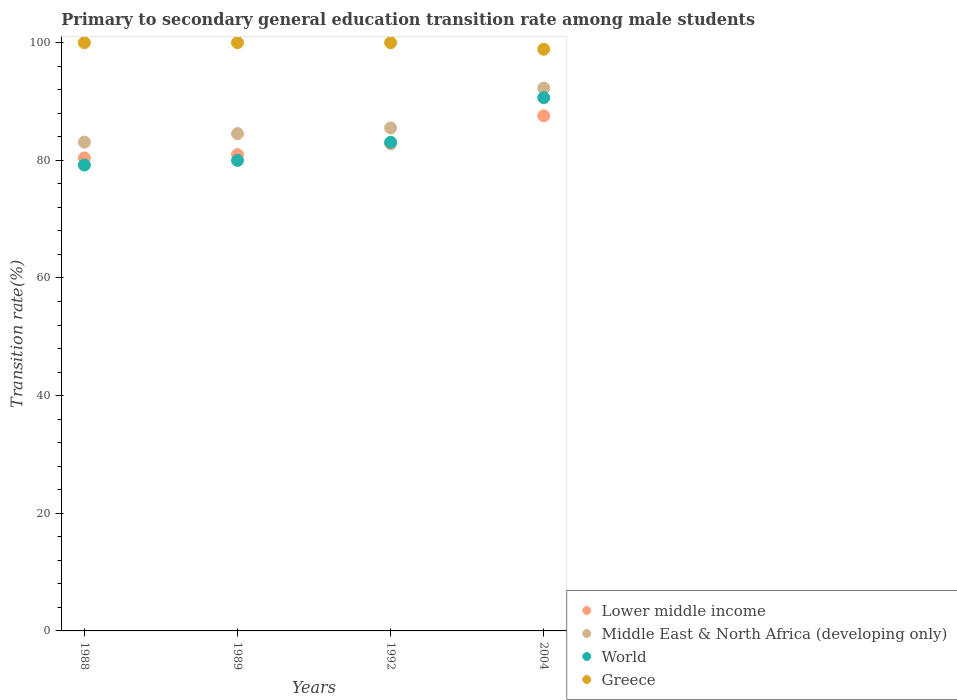How many different coloured dotlines are there?
Make the answer very short. 4. What is the transition rate in Greece in 2004?
Your answer should be compact. 98.88. Across all years, what is the maximum transition rate in World?
Offer a very short reply. 90.65. Across all years, what is the minimum transition rate in Lower middle income?
Offer a terse response. 80.41. What is the total transition rate in Lower middle income in the graph?
Provide a succinct answer. 331.79. What is the difference between the transition rate in Lower middle income in 1988 and that in 1989?
Your response must be concise. -0.56. What is the difference between the transition rate in Greece in 1992 and the transition rate in Lower middle income in 1989?
Keep it short and to the point. 19.02. What is the average transition rate in Lower middle income per year?
Provide a succinct answer. 82.95. In the year 2004, what is the difference between the transition rate in Lower middle income and transition rate in Middle East & North Africa (developing only)?
Keep it short and to the point. -4.71. What is the ratio of the transition rate in Greece in 1992 to that in 2004?
Offer a terse response. 1.01. Is the transition rate in Greece in 1989 less than that in 1992?
Your answer should be very brief. No. What is the difference between the highest and the lowest transition rate in World?
Offer a very short reply. 11.45. In how many years, is the transition rate in Lower middle income greater than the average transition rate in Lower middle income taken over all years?
Offer a terse response. 1. Is the sum of the transition rate in Middle East & North Africa (developing only) in 1992 and 2004 greater than the maximum transition rate in World across all years?
Provide a short and direct response. Yes. Is it the case that in every year, the sum of the transition rate in Middle East & North Africa (developing only) and transition rate in World  is greater than the sum of transition rate in Lower middle income and transition rate in Greece?
Your answer should be compact. No. Does the transition rate in World monotonically increase over the years?
Provide a succinct answer. Yes. Is the transition rate in Lower middle income strictly greater than the transition rate in Middle East & North Africa (developing only) over the years?
Offer a very short reply. No. Is the transition rate in Lower middle income strictly less than the transition rate in World over the years?
Offer a very short reply. No. How many years are there in the graph?
Give a very brief answer. 4. What is the difference between two consecutive major ticks on the Y-axis?
Offer a terse response. 20. Are the values on the major ticks of Y-axis written in scientific E-notation?
Give a very brief answer. No. Does the graph contain any zero values?
Ensure brevity in your answer.  No. Does the graph contain grids?
Your answer should be compact. No. How are the legend labels stacked?
Your answer should be very brief. Vertical. What is the title of the graph?
Keep it short and to the point. Primary to secondary general education transition rate among male students. What is the label or title of the X-axis?
Provide a succinct answer. Years. What is the label or title of the Y-axis?
Give a very brief answer. Transition rate(%). What is the Transition rate(%) in Lower middle income in 1988?
Your response must be concise. 80.41. What is the Transition rate(%) of Middle East & North Africa (developing only) in 1988?
Offer a very short reply. 83.1. What is the Transition rate(%) of World in 1988?
Ensure brevity in your answer.  79.2. What is the Transition rate(%) of Greece in 1988?
Your answer should be very brief. 100. What is the Transition rate(%) of Lower middle income in 1989?
Your answer should be very brief. 80.98. What is the Transition rate(%) of Middle East & North Africa (developing only) in 1989?
Give a very brief answer. 84.54. What is the Transition rate(%) in World in 1989?
Keep it short and to the point. 79.98. What is the Transition rate(%) in Lower middle income in 1992?
Give a very brief answer. 82.83. What is the Transition rate(%) of Middle East & North Africa (developing only) in 1992?
Offer a very short reply. 85.51. What is the Transition rate(%) of World in 1992?
Offer a terse response. 83.07. What is the Transition rate(%) of Greece in 1992?
Ensure brevity in your answer.  100. What is the Transition rate(%) in Lower middle income in 2004?
Your response must be concise. 87.57. What is the Transition rate(%) of Middle East & North Africa (developing only) in 2004?
Ensure brevity in your answer.  92.29. What is the Transition rate(%) of World in 2004?
Offer a terse response. 90.65. What is the Transition rate(%) in Greece in 2004?
Give a very brief answer. 98.88. Across all years, what is the maximum Transition rate(%) of Lower middle income?
Ensure brevity in your answer.  87.57. Across all years, what is the maximum Transition rate(%) in Middle East & North Africa (developing only)?
Provide a succinct answer. 92.29. Across all years, what is the maximum Transition rate(%) in World?
Provide a short and direct response. 90.65. Across all years, what is the maximum Transition rate(%) in Greece?
Provide a short and direct response. 100. Across all years, what is the minimum Transition rate(%) of Lower middle income?
Offer a very short reply. 80.41. Across all years, what is the minimum Transition rate(%) of Middle East & North Africa (developing only)?
Your answer should be very brief. 83.1. Across all years, what is the minimum Transition rate(%) in World?
Give a very brief answer. 79.2. Across all years, what is the minimum Transition rate(%) in Greece?
Offer a terse response. 98.88. What is the total Transition rate(%) of Lower middle income in the graph?
Provide a succinct answer. 331.79. What is the total Transition rate(%) in Middle East & North Africa (developing only) in the graph?
Offer a very short reply. 345.44. What is the total Transition rate(%) of World in the graph?
Give a very brief answer. 332.9. What is the total Transition rate(%) of Greece in the graph?
Your answer should be very brief. 398.88. What is the difference between the Transition rate(%) of Lower middle income in 1988 and that in 1989?
Your answer should be very brief. -0.56. What is the difference between the Transition rate(%) in Middle East & North Africa (developing only) in 1988 and that in 1989?
Keep it short and to the point. -1.45. What is the difference between the Transition rate(%) in World in 1988 and that in 1989?
Your answer should be very brief. -0.78. What is the difference between the Transition rate(%) of Lower middle income in 1988 and that in 1992?
Offer a very short reply. -2.42. What is the difference between the Transition rate(%) in Middle East & North Africa (developing only) in 1988 and that in 1992?
Keep it short and to the point. -2.41. What is the difference between the Transition rate(%) of World in 1988 and that in 1992?
Ensure brevity in your answer.  -3.87. What is the difference between the Transition rate(%) of Greece in 1988 and that in 1992?
Your answer should be compact. 0. What is the difference between the Transition rate(%) in Lower middle income in 1988 and that in 2004?
Give a very brief answer. -7.16. What is the difference between the Transition rate(%) in Middle East & North Africa (developing only) in 1988 and that in 2004?
Your response must be concise. -9.19. What is the difference between the Transition rate(%) in World in 1988 and that in 2004?
Your response must be concise. -11.45. What is the difference between the Transition rate(%) in Greece in 1988 and that in 2004?
Make the answer very short. 1.12. What is the difference between the Transition rate(%) of Lower middle income in 1989 and that in 1992?
Offer a terse response. -1.86. What is the difference between the Transition rate(%) of Middle East & North Africa (developing only) in 1989 and that in 1992?
Your answer should be very brief. -0.96. What is the difference between the Transition rate(%) of World in 1989 and that in 1992?
Offer a very short reply. -3.08. What is the difference between the Transition rate(%) in Lower middle income in 1989 and that in 2004?
Make the answer very short. -6.6. What is the difference between the Transition rate(%) of Middle East & North Africa (developing only) in 1989 and that in 2004?
Your response must be concise. -7.74. What is the difference between the Transition rate(%) in World in 1989 and that in 2004?
Your answer should be compact. -10.67. What is the difference between the Transition rate(%) in Greece in 1989 and that in 2004?
Your answer should be very brief. 1.12. What is the difference between the Transition rate(%) of Lower middle income in 1992 and that in 2004?
Make the answer very short. -4.74. What is the difference between the Transition rate(%) in Middle East & North Africa (developing only) in 1992 and that in 2004?
Your answer should be compact. -6.78. What is the difference between the Transition rate(%) in World in 1992 and that in 2004?
Keep it short and to the point. -7.58. What is the difference between the Transition rate(%) in Greece in 1992 and that in 2004?
Your answer should be compact. 1.12. What is the difference between the Transition rate(%) of Lower middle income in 1988 and the Transition rate(%) of Middle East & North Africa (developing only) in 1989?
Keep it short and to the point. -4.13. What is the difference between the Transition rate(%) in Lower middle income in 1988 and the Transition rate(%) in World in 1989?
Your answer should be compact. 0.43. What is the difference between the Transition rate(%) of Lower middle income in 1988 and the Transition rate(%) of Greece in 1989?
Provide a succinct answer. -19.59. What is the difference between the Transition rate(%) of Middle East & North Africa (developing only) in 1988 and the Transition rate(%) of World in 1989?
Provide a succinct answer. 3.11. What is the difference between the Transition rate(%) of Middle East & North Africa (developing only) in 1988 and the Transition rate(%) of Greece in 1989?
Your response must be concise. -16.9. What is the difference between the Transition rate(%) in World in 1988 and the Transition rate(%) in Greece in 1989?
Ensure brevity in your answer.  -20.8. What is the difference between the Transition rate(%) of Lower middle income in 1988 and the Transition rate(%) of Middle East & North Africa (developing only) in 1992?
Provide a short and direct response. -5.1. What is the difference between the Transition rate(%) of Lower middle income in 1988 and the Transition rate(%) of World in 1992?
Provide a short and direct response. -2.66. What is the difference between the Transition rate(%) of Lower middle income in 1988 and the Transition rate(%) of Greece in 1992?
Your answer should be compact. -19.59. What is the difference between the Transition rate(%) of Middle East & North Africa (developing only) in 1988 and the Transition rate(%) of Greece in 1992?
Your response must be concise. -16.9. What is the difference between the Transition rate(%) of World in 1988 and the Transition rate(%) of Greece in 1992?
Provide a short and direct response. -20.8. What is the difference between the Transition rate(%) in Lower middle income in 1988 and the Transition rate(%) in Middle East & North Africa (developing only) in 2004?
Provide a succinct answer. -11.88. What is the difference between the Transition rate(%) of Lower middle income in 1988 and the Transition rate(%) of World in 2004?
Your answer should be compact. -10.24. What is the difference between the Transition rate(%) in Lower middle income in 1988 and the Transition rate(%) in Greece in 2004?
Keep it short and to the point. -18.47. What is the difference between the Transition rate(%) of Middle East & North Africa (developing only) in 1988 and the Transition rate(%) of World in 2004?
Offer a terse response. -7.55. What is the difference between the Transition rate(%) in Middle East & North Africa (developing only) in 1988 and the Transition rate(%) in Greece in 2004?
Offer a very short reply. -15.79. What is the difference between the Transition rate(%) in World in 1988 and the Transition rate(%) in Greece in 2004?
Offer a very short reply. -19.68. What is the difference between the Transition rate(%) in Lower middle income in 1989 and the Transition rate(%) in Middle East & North Africa (developing only) in 1992?
Give a very brief answer. -4.53. What is the difference between the Transition rate(%) in Lower middle income in 1989 and the Transition rate(%) in World in 1992?
Your response must be concise. -2.09. What is the difference between the Transition rate(%) of Lower middle income in 1989 and the Transition rate(%) of Greece in 1992?
Give a very brief answer. -19.02. What is the difference between the Transition rate(%) of Middle East & North Africa (developing only) in 1989 and the Transition rate(%) of World in 1992?
Keep it short and to the point. 1.48. What is the difference between the Transition rate(%) of Middle East & North Africa (developing only) in 1989 and the Transition rate(%) of Greece in 1992?
Provide a succinct answer. -15.46. What is the difference between the Transition rate(%) of World in 1989 and the Transition rate(%) of Greece in 1992?
Give a very brief answer. -20.02. What is the difference between the Transition rate(%) in Lower middle income in 1989 and the Transition rate(%) in Middle East & North Africa (developing only) in 2004?
Your response must be concise. -11.31. What is the difference between the Transition rate(%) in Lower middle income in 1989 and the Transition rate(%) in World in 2004?
Your response must be concise. -9.68. What is the difference between the Transition rate(%) of Lower middle income in 1989 and the Transition rate(%) of Greece in 2004?
Keep it short and to the point. -17.91. What is the difference between the Transition rate(%) of Middle East & North Africa (developing only) in 1989 and the Transition rate(%) of World in 2004?
Make the answer very short. -6.11. What is the difference between the Transition rate(%) in Middle East & North Africa (developing only) in 1989 and the Transition rate(%) in Greece in 2004?
Your response must be concise. -14.34. What is the difference between the Transition rate(%) of World in 1989 and the Transition rate(%) of Greece in 2004?
Keep it short and to the point. -18.9. What is the difference between the Transition rate(%) of Lower middle income in 1992 and the Transition rate(%) of Middle East & North Africa (developing only) in 2004?
Make the answer very short. -9.46. What is the difference between the Transition rate(%) of Lower middle income in 1992 and the Transition rate(%) of World in 2004?
Your response must be concise. -7.82. What is the difference between the Transition rate(%) in Lower middle income in 1992 and the Transition rate(%) in Greece in 2004?
Provide a short and direct response. -16.05. What is the difference between the Transition rate(%) in Middle East & North Africa (developing only) in 1992 and the Transition rate(%) in World in 2004?
Provide a succinct answer. -5.14. What is the difference between the Transition rate(%) of Middle East & North Africa (developing only) in 1992 and the Transition rate(%) of Greece in 2004?
Ensure brevity in your answer.  -13.38. What is the difference between the Transition rate(%) of World in 1992 and the Transition rate(%) of Greece in 2004?
Give a very brief answer. -15.82. What is the average Transition rate(%) in Lower middle income per year?
Your response must be concise. 82.95. What is the average Transition rate(%) in Middle East & North Africa (developing only) per year?
Your answer should be compact. 86.36. What is the average Transition rate(%) of World per year?
Make the answer very short. 83.23. What is the average Transition rate(%) in Greece per year?
Ensure brevity in your answer.  99.72. In the year 1988, what is the difference between the Transition rate(%) of Lower middle income and Transition rate(%) of Middle East & North Africa (developing only)?
Your answer should be compact. -2.69. In the year 1988, what is the difference between the Transition rate(%) of Lower middle income and Transition rate(%) of World?
Offer a terse response. 1.21. In the year 1988, what is the difference between the Transition rate(%) of Lower middle income and Transition rate(%) of Greece?
Your answer should be compact. -19.59. In the year 1988, what is the difference between the Transition rate(%) of Middle East & North Africa (developing only) and Transition rate(%) of World?
Your answer should be compact. 3.9. In the year 1988, what is the difference between the Transition rate(%) in Middle East & North Africa (developing only) and Transition rate(%) in Greece?
Provide a succinct answer. -16.9. In the year 1988, what is the difference between the Transition rate(%) of World and Transition rate(%) of Greece?
Keep it short and to the point. -20.8. In the year 1989, what is the difference between the Transition rate(%) of Lower middle income and Transition rate(%) of Middle East & North Africa (developing only)?
Offer a terse response. -3.57. In the year 1989, what is the difference between the Transition rate(%) of Lower middle income and Transition rate(%) of Greece?
Your answer should be very brief. -19.02. In the year 1989, what is the difference between the Transition rate(%) in Middle East & North Africa (developing only) and Transition rate(%) in World?
Your answer should be compact. 4.56. In the year 1989, what is the difference between the Transition rate(%) in Middle East & North Africa (developing only) and Transition rate(%) in Greece?
Give a very brief answer. -15.46. In the year 1989, what is the difference between the Transition rate(%) of World and Transition rate(%) of Greece?
Provide a short and direct response. -20.02. In the year 1992, what is the difference between the Transition rate(%) of Lower middle income and Transition rate(%) of Middle East & North Africa (developing only)?
Provide a succinct answer. -2.67. In the year 1992, what is the difference between the Transition rate(%) of Lower middle income and Transition rate(%) of World?
Your response must be concise. -0.23. In the year 1992, what is the difference between the Transition rate(%) in Lower middle income and Transition rate(%) in Greece?
Ensure brevity in your answer.  -17.17. In the year 1992, what is the difference between the Transition rate(%) of Middle East & North Africa (developing only) and Transition rate(%) of World?
Keep it short and to the point. 2.44. In the year 1992, what is the difference between the Transition rate(%) of Middle East & North Africa (developing only) and Transition rate(%) of Greece?
Offer a terse response. -14.49. In the year 1992, what is the difference between the Transition rate(%) of World and Transition rate(%) of Greece?
Give a very brief answer. -16.93. In the year 2004, what is the difference between the Transition rate(%) in Lower middle income and Transition rate(%) in Middle East & North Africa (developing only)?
Your response must be concise. -4.71. In the year 2004, what is the difference between the Transition rate(%) of Lower middle income and Transition rate(%) of World?
Your response must be concise. -3.08. In the year 2004, what is the difference between the Transition rate(%) of Lower middle income and Transition rate(%) of Greece?
Give a very brief answer. -11.31. In the year 2004, what is the difference between the Transition rate(%) of Middle East & North Africa (developing only) and Transition rate(%) of World?
Your answer should be compact. 1.64. In the year 2004, what is the difference between the Transition rate(%) of Middle East & North Africa (developing only) and Transition rate(%) of Greece?
Ensure brevity in your answer.  -6.59. In the year 2004, what is the difference between the Transition rate(%) in World and Transition rate(%) in Greece?
Your answer should be compact. -8.23. What is the ratio of the Transition rate(%) in Middle East & North Africa (developing only) in 1988 to that in 1989?
Offer a terse response. 0.98. What is the ratio of the Transition rate(%) in World in 1988 to that in 1989?
Your response must be concise. 0.99. What is the ratio of the Transition rate(%) of Lower middle income in 1988 to that in 1992?
Your answer should be compact. 0.97. What is the ratio of the Transition rate(%) of Middle East & North Africa (developing only) in 1988 to that in 1992?
Make the answer very short. 0.97. What is the ratio of the Transition rate(%) in World in 1988 to that in 1992?
Keep it short and to the point. 0.95. What is the ratio of the Transition rate(%) in Greece in 1988 to that in 1992?
Keep it short and to the point. 1. What is the ratio of the Transition rate(%) in Lower middle income in 1988 to that in 2004?
Ensure brevity in your answer.  0.92. What is the ratio of the Transition rate(%) in Middle East & North Africa (developing only) in 1988 to that in 2004?
Keep it short and to the point. 0.9. What is the ratio of the Transition rate(%) of World in 1988 to that in 2004?
Provide a short and direct response. 0.87. What is the ratio of the Transition rate(%) of Greece in 1988 to that in 2004?
Ensure brevity in your answer.  1.01. What is the ratio of the Transition rate(%) of Lower middle income in 1989 to that in 1992?
Provide a succinct answer. 0.98. What is the ratio of the Transition rate(%) of Middle East & North Africa (developing only) in 1989 to that in 1992?
Provide a short and direct response. 0.99. What is the ratio of the Transition rate(%) of World in 1989 to that in 1992?
Provide a succinct answer. 0.96. What is the ratio of the Transition rate(%) of Lower middle income in 1989 to that in 2004?
Your answer should be very brief. 0.92. What is the ratio of the Transition rate(%) in Middle East & North Africa (developing only) in 1989 to that in 2004?
Offer a very short reply. 0.92. What is the ratio of the Transition rate(%) of World in 1989 to that in 2004?
Make the answer very short. 0.88. What is the ratio of the Transition rate(%) in Greece in 1989 to that in 2004?
Offer a terse response. 1.01. What is the ratio of the Transition rate(%) of Lower middle income in 1992 to that in 2004?
Your answer should be compact. 0.95. What is the ratio of the Transition rate(%) of Middle East & North Africa (developing only) in 1992 to that in 2004?
Provide a short and direct response. 0.93. What is the ratio of the Transition rate(%) of World in 1992 to that in 2004?
Offer a terse response. 0.92. What is the ratio of the Transition rate(%) of Greece in 1992 to that in 2004?
Keep it short and to the point. 1.01. What is the difference between the highest and the second highest Transition rate(%) in Lower middle income?
Ensure brevity in your answer.  4.74. What is the difference between the highest and the second highest Transition rate(%) of Middle East & North Africa (developing only)?
Provide a short and direct response. 6.78. What is the difference between the highest and the second highest Transition rate(%) in World?
Make the answer very short. 7.58. What is the difference between the highest and the lowest Transition rate(%) in Lower middle income?
Offer a terse response. 7.16. What is the difference between the highest and the lowest Transition rate(%) of Middle East & North Africa (developing only)?
Provide a succinct answer. 9.19. What is the difference between the highest and the lowest Transition rate(%) in World?
Provide a short and direct response. 11.45. What is the difference between the highest and the lowest Transition rate(%) of Greece?
Make the answer very short. 1.12. 